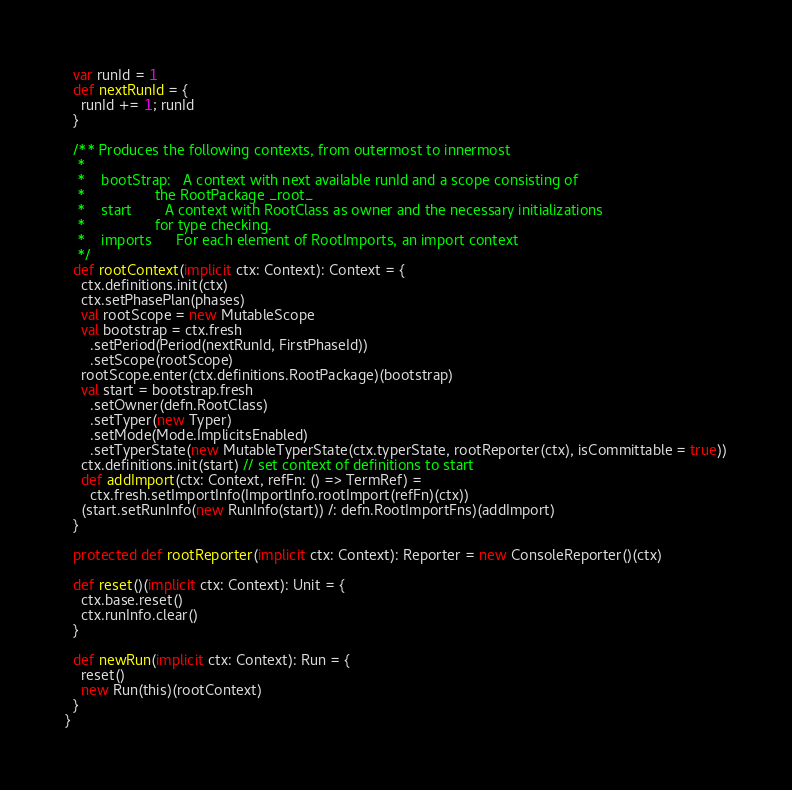<code> <loc_0><loc_0><loc_500><loc_500><_Scala_>  var runId = 1
  def nextRunId = {
    runId += 1; runId
  }

  /** Produces the following contexts, from outermost to innermost
   *
   *    bootStrap:   A context with next available runId and a scope consisting of
   *                 the RootPackage _root_
   *    start        A context with RootClass as owner and the necessary initializations
   *                 for type checking.
   *    imports      For each element of RootImports, an import context
   */
  def rootContext(implicit ctx: Context): Context = {
    ctx.definitions.init(ctx)
    ctx.setPhasePlan(phases)
    val rootScope = new MutableScope
    val bootstrap = ctx.fresh
      .setPeriod(Period(nextRunId, FirstPhaseId))
      .setScope(rootScope)
    rootScope.enter(ctx.definitions.RootPackage)(bootstrap)
    val start = bootstrap.fresh
      .setOwner(defn.RootClass)
      .setTyper(new Typer)
      .setMode(Mode.ImplicitsEnabled)
      .setTyperState(new MutableTyperState(ctx.typerState, rootReporter(ctx), isCommittable = true))
    ctx.definitions.init(start) // set context of definitions to start
    def addImport(ctx: Context, refFn: () => TermRef) =
      ctx.fresh.setImportInfo(ImportInfo.rootImport(refFn)(ctx))
    (start.setRunInfo(new RunInfo(start)) /: defn.RootImportFns)(addImport)
  }

  protected def rootReporter(implicit ctx: Context): Reporter = new ConsoleReporter()(ctx)

  def reset()(implicit ctx: Context): Unit = {
    ctx.base.reset()
    ctx.runInfo.clear()
  }

  def newRun(implicit ctx: Context): Run = {
    reset()
    new Run(this)(rootContext)
  }
}
</code> 